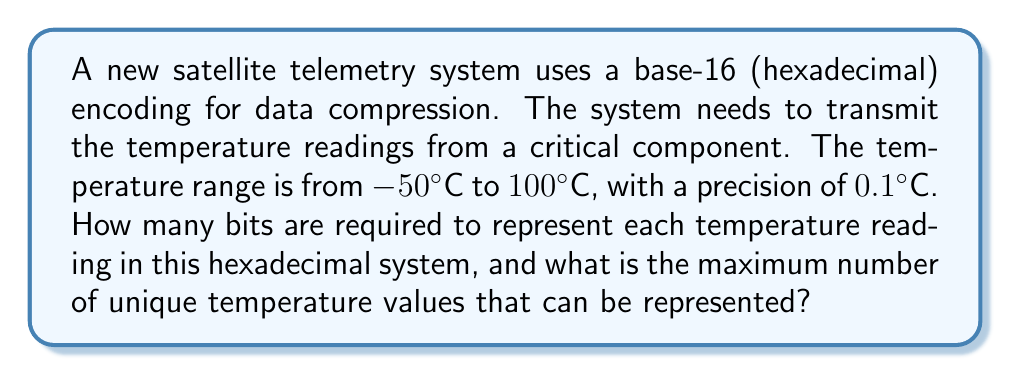Could you help me with this problem? Let's approach this step-by-step:

1) First, we need to calculate the total number of unique temperature values:
   Range: -50°C to 100°C
   Precision: 0.1°C
   Total unique values = $\frac{100 - (-50)}{0.1} + 1 = \frac{150}{0.1} + 1 = 1501$

2) Now, we need to find how many hexadecimal digits are needed to represent 1501 unique values.

3) In hexadecimal (base-16), each digit can represent 16 values (0-9, A-F).
   Let $n$ be the number of hexadecimal digits.
   We need: $16^n \geq 1501$

4) Taking $\log_{16}$ of both sides:
   $n \geq \log_{16}(1501)$

5) $\log_{16}(1501) \approx 2.7384$

6) Since $n$ must be an integer, we round up to the nearest whole number:
   $n = 3$

7) With 3 hexadecimal digits, we can represent:
   $16^3 = 4096$ unique values

8) To convert hexadecimal digits to bits:
   3 hexadecimal digits = $3 \times 4 = 12$ bits
   (Each hexadecimal digit requires 4 bits)

Therefore, 12 bits are required to represent each temperature reading in this hexadecimal system, and the maximum number of unique temperature values that can be represented is 4096.
Answer: 12 bits are required, and 4096 unique temperature values can be represented. 